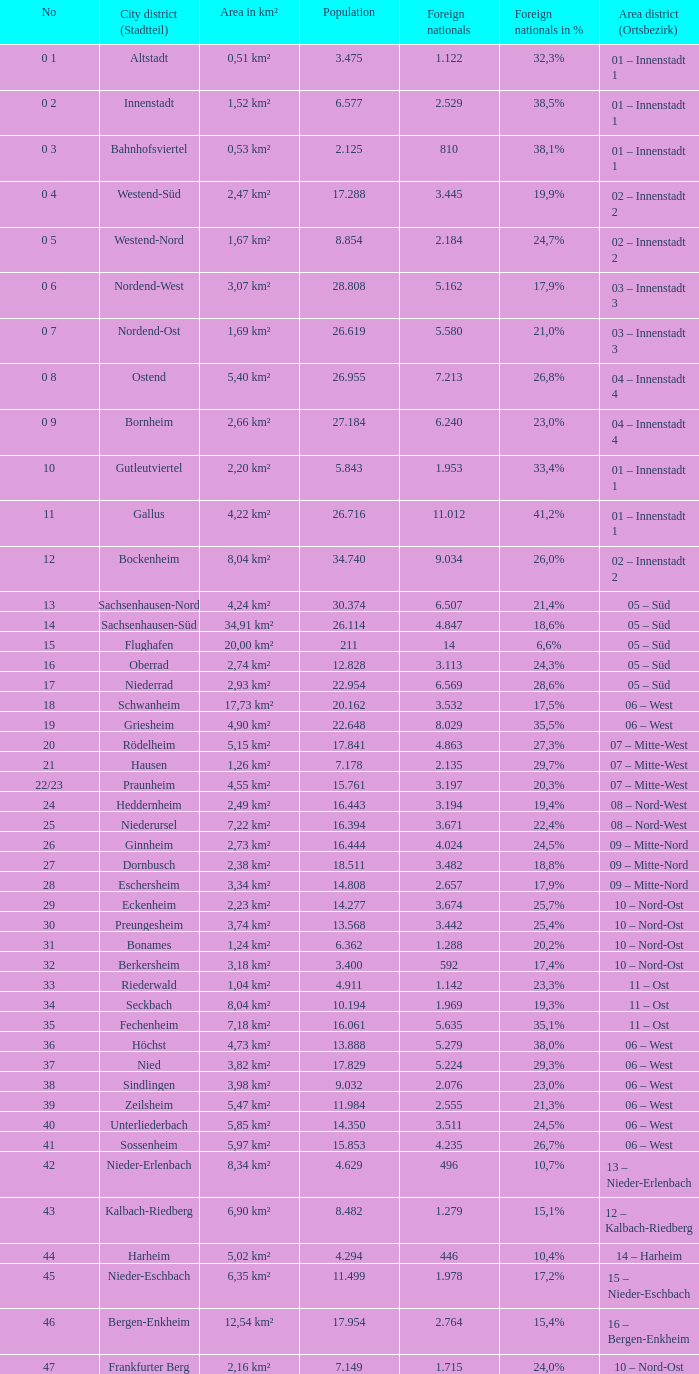What is the city where the number is 47? Frankfurter Berg. 